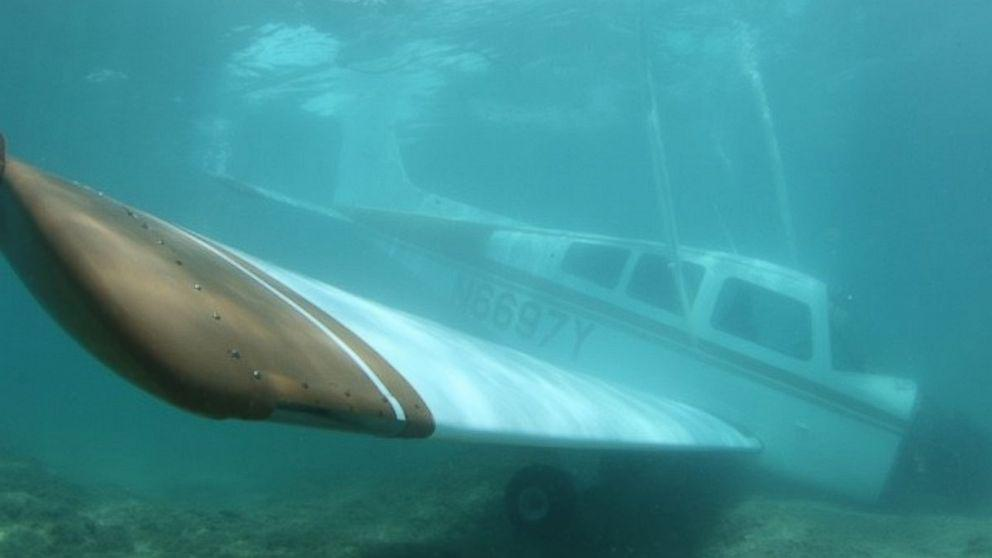How many unicorns would there be in the image after no additional unicorn was added in the image? There are no unicorns visible in the image. If no additional unicorns were added, there would still be zero unicorns. 